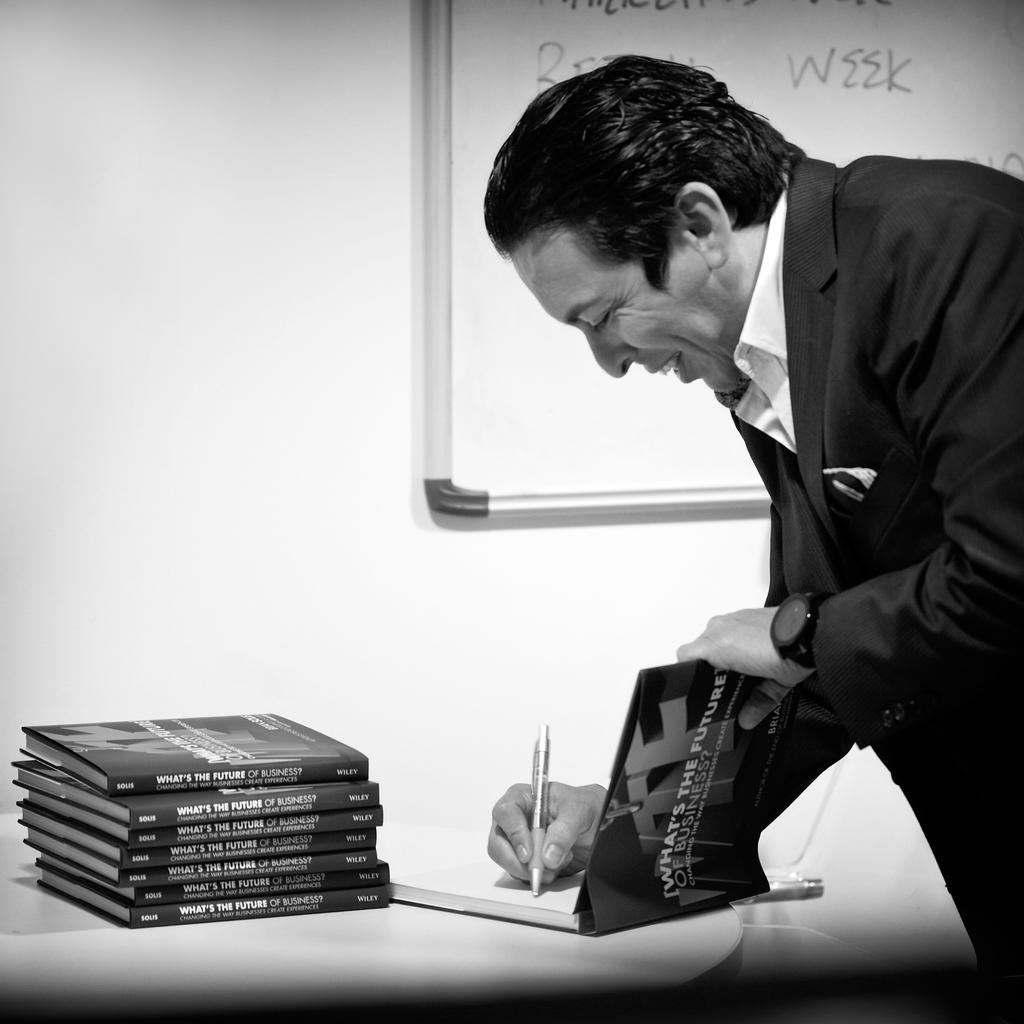What work is on the white board?
Your response must be concise. Week. 